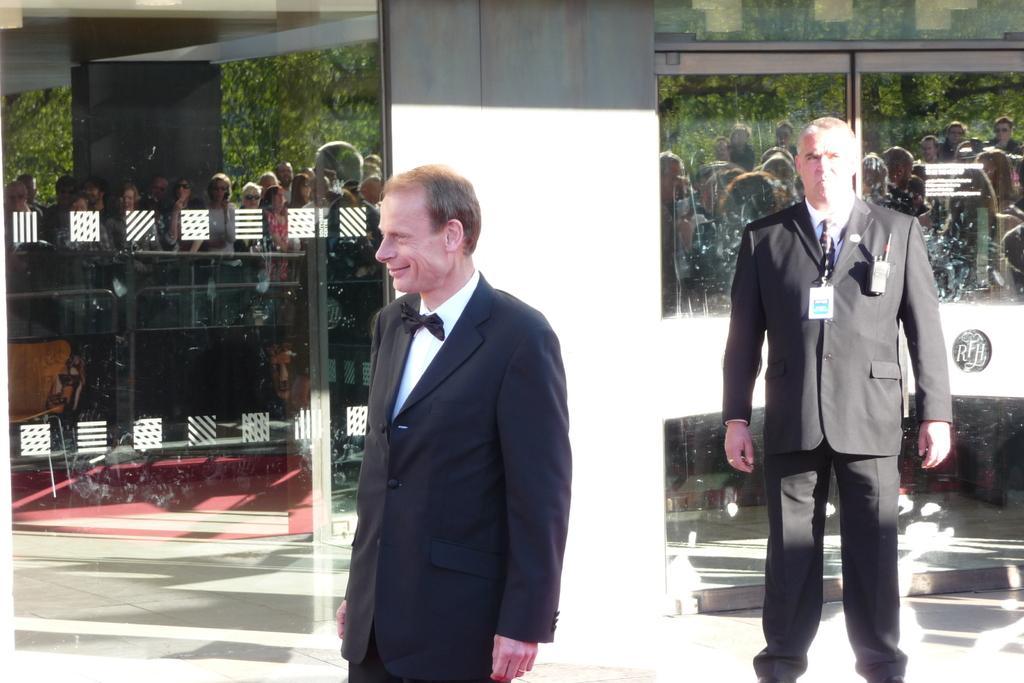Could you give a brief overview of what you see in this image? There are two persons standing. Person in the back is wearing a tag and having a phone on the coat. In the back there is a pillar and glass walls. On the glass there are reflections of people, trees and pillar. 